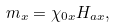Convert formula to latex. <formula><loc_0><loc_0><loc_500><loc_500>m _ { x } = \chi _ { 0 x } H _ { a x } ,</formula> 